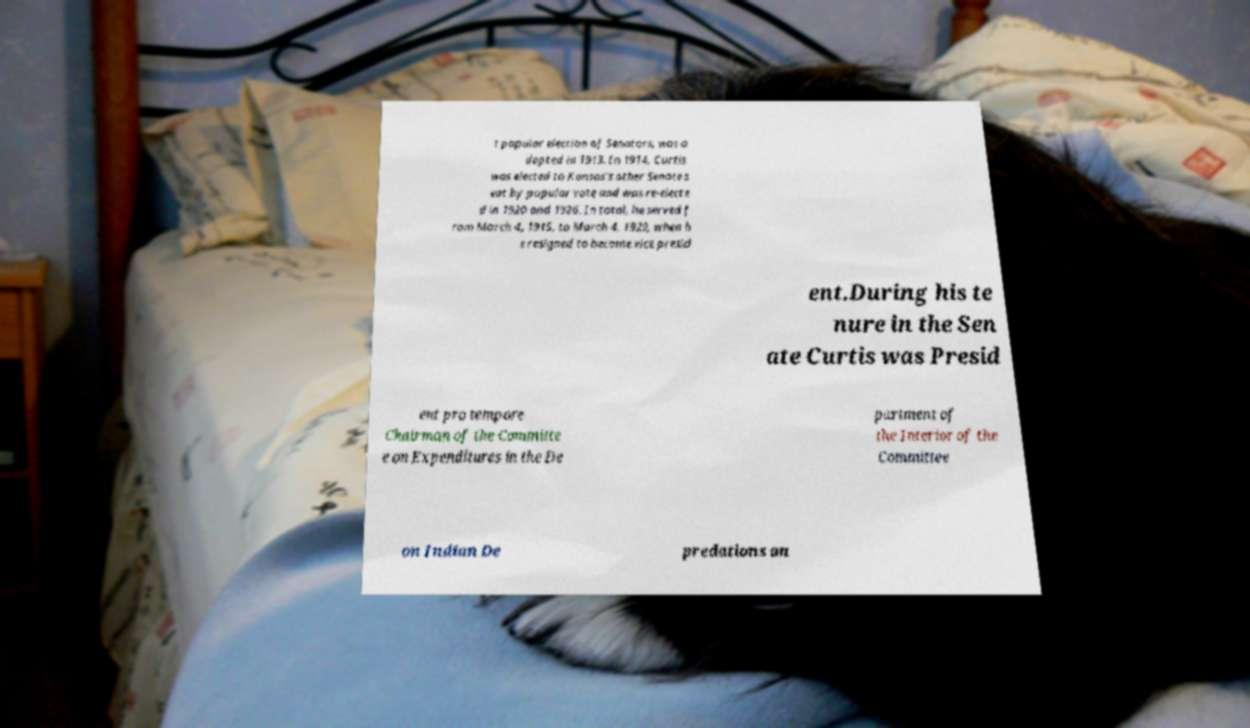For documentation purposes, I need the text within this image transcribed. Could you provide that? t popular election of Senators, was a dopted in 1913. In 1914, Curtis was elected to Kansas's other Senate s eat by popular vote and was re-electe d in 1920 and 1926. In total, he served f rom March 4, 1915, to March 4, 1929, when h e resigned to become vice presid ent.During his te nure in the Sen ate Curtis was Presid ent pro tempore Chairman of the Committe e on Expenditures in the De partment of the Interior of the Committee on Indian De predations an 